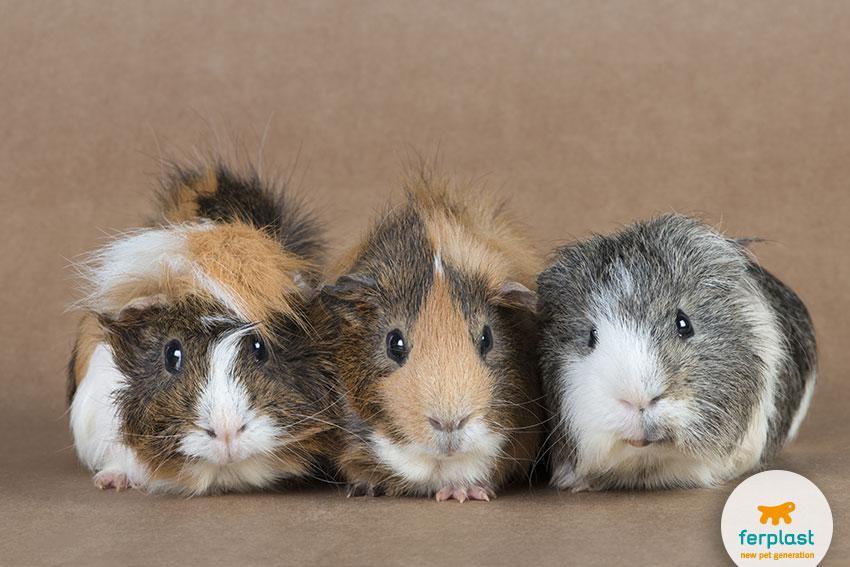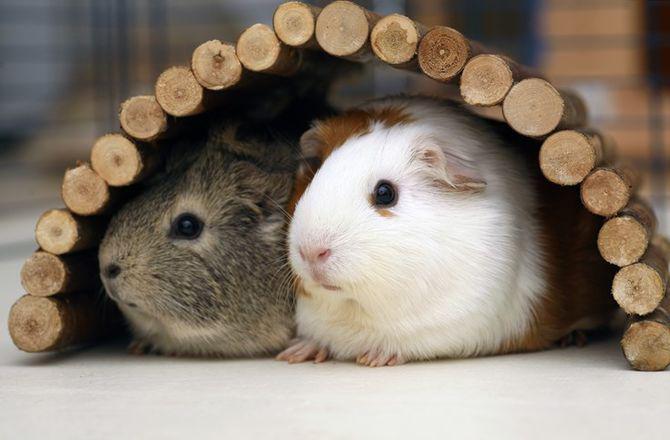The first image is the image on the left, the second image is the image on the right. Analyze the images presented: Is the assertion "there are 3 guinea pigs in each image pair" valid? Answer yes or no. No. The first image is the image on the left, the second image is the image on the right. For the images shown, is this caption "In the right image, the animals have something covering their heads." true? Answer yes or no. Yes. 